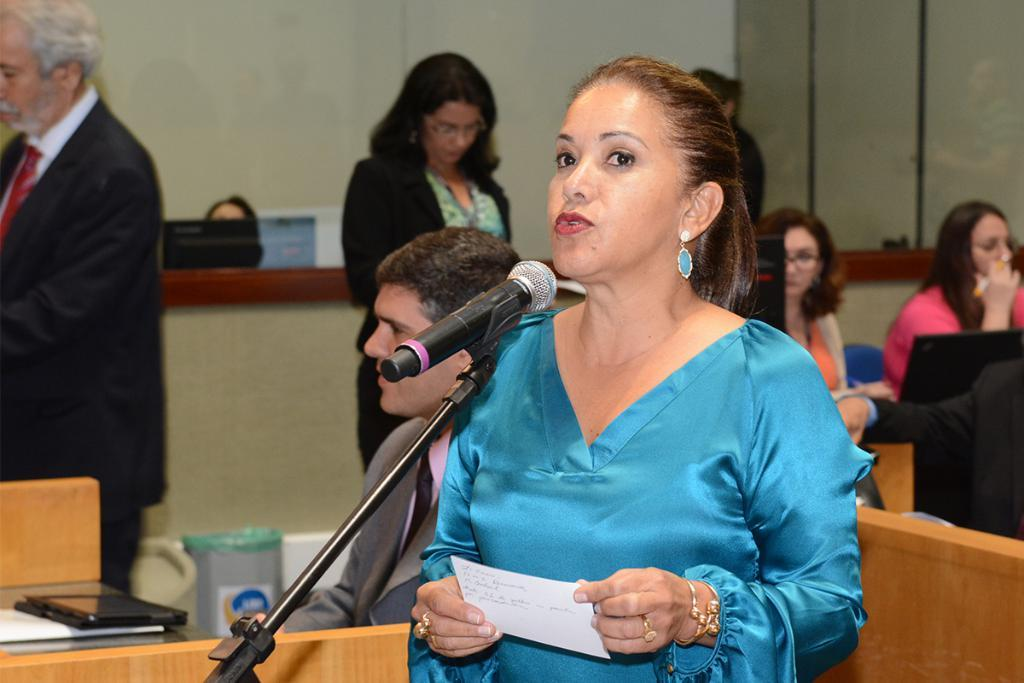How many people are in the room? There are people in the room, but the exact number is not specified. Can you describe the woman in the room? The woman in the room is in front of a microphone and holding a paper. What is the woman doing in the room? The woman is talking. What type of sponge is the woman using to clean the microphone in the image? There is no sponge present in the image, and the woman is not cleaning the microphone. 